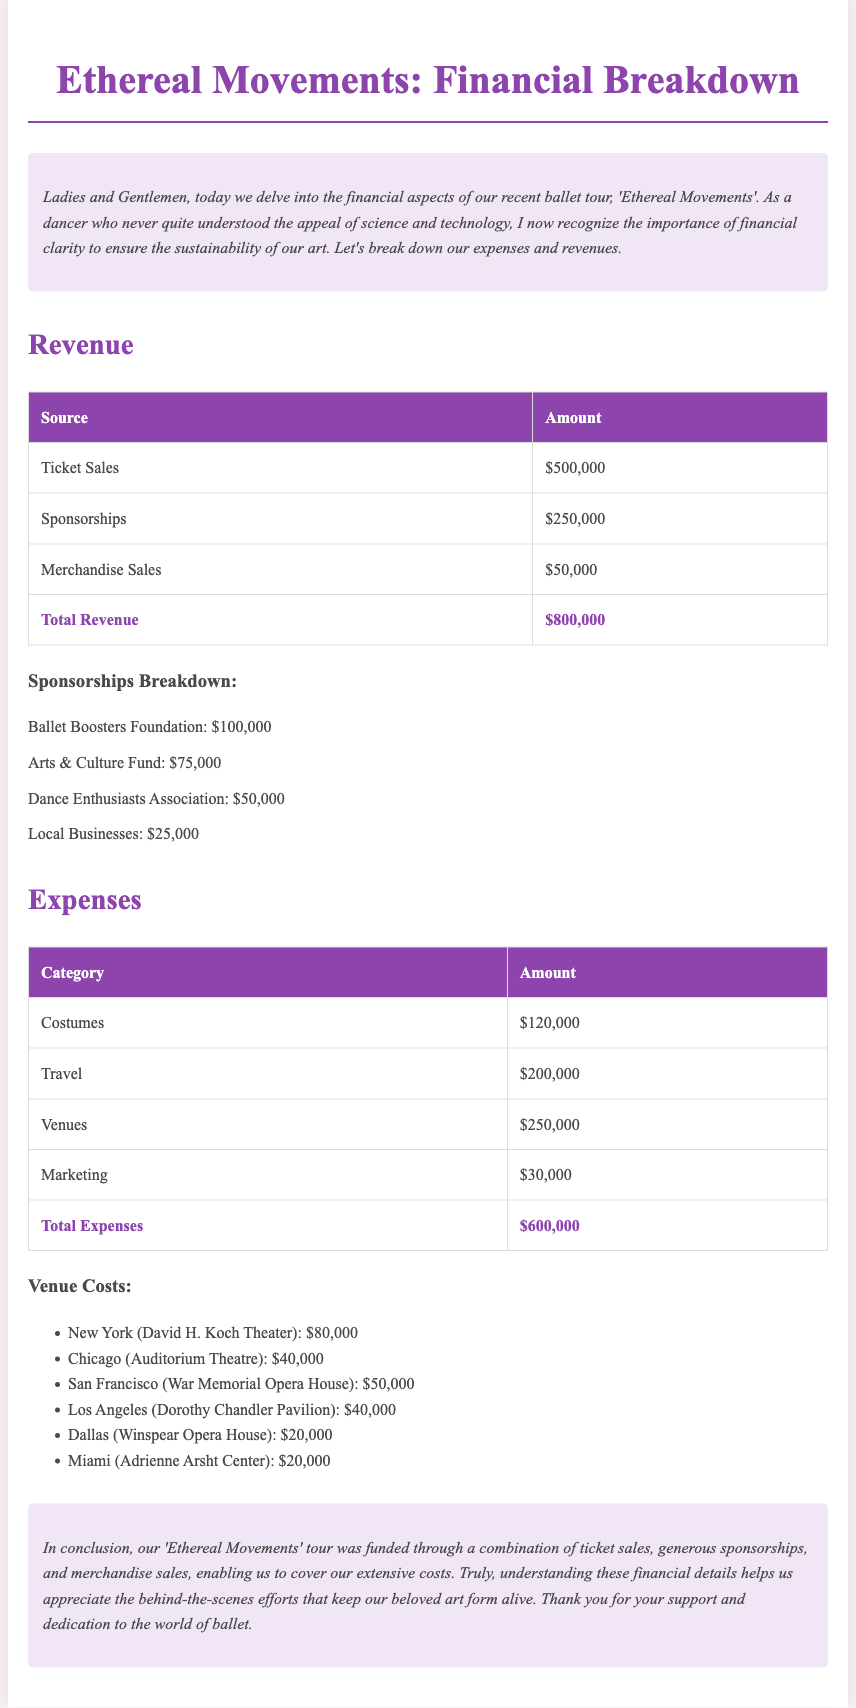What is the total revenue? The total revenue is the sum of all revenue sources listed in the document, which includes ticket sales, sponsorships, and merchandise sales.
Answer: $800,000 What is the sponsorship amount from the Ballet Boosters Foundation? The document specifies that the Ballet Boosters Foundation contributed $100,000 to the tour.
Answer: $100,000 How much was spent on costumes? The expenses table indicates that the amount spent on costumes is $120,000.
Answer: $120,000 What venue had the highest cost? The Venues section outlines that the highest cost for a venue was $80,000 for the New York location.
Answer: New York (David H. Koch Theater) What was the total expense amount? The total expenses column sums to $600,000, as indicated in the expenses table.
Answer: $600,000 Which category had the lowest expense? The expenses table shows that Marketing had the lowest expense of $30,000.
Answer: Marketing How many sources of revenue are listed? The document lists three sources of revenue: Ticket Sales, Sponsorships, and Merchandise Sales.
Answer: Three What percentage of total revenue came from ticket sales? Ticket sales amount to $500,000, which is 62.5% of the total revenue of $800,000.
Answer: 62.5% What type of fundraiser was 'Ethereal Movements'? The document describes 'Ethereal Movements' as a ballet tour.
Answer: Ballet tour 